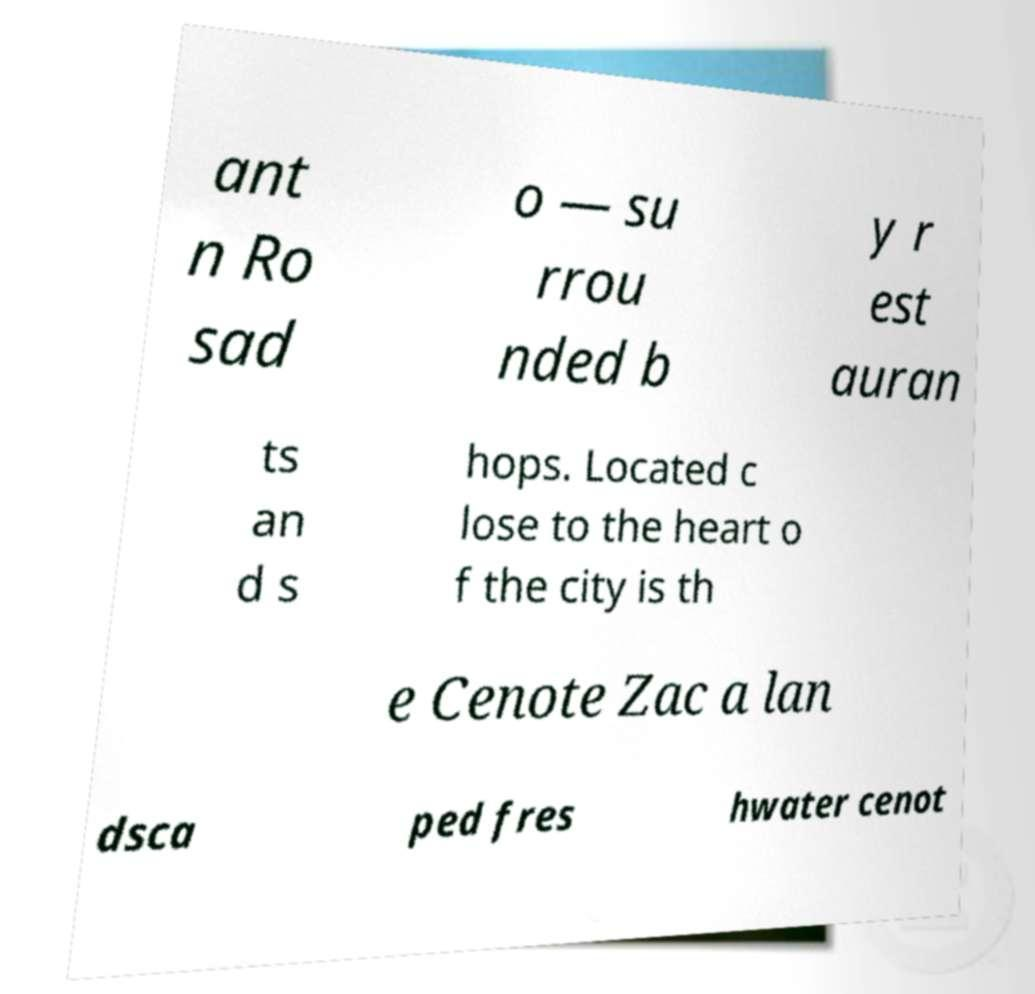Can you accurately transcribe the text from the provided image for me? ant n Ro sad o — su rrou nded b y r est auran ts an d s hops. Located c lose to the heart o f the city is th e Cenote Zac a lan dsca ped fres hwater cenot 